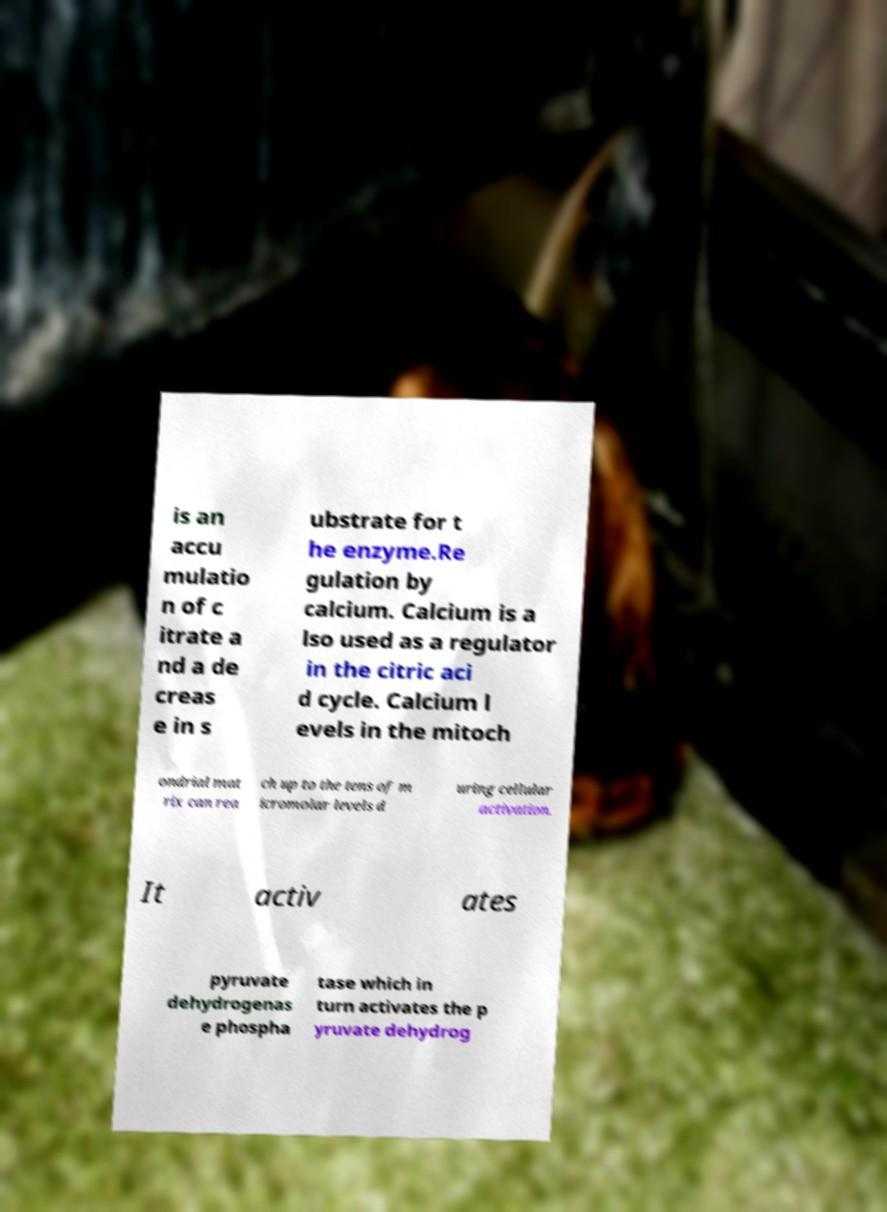What messages or text are displayed in this image? I need them in a readable, typed format. is an accu mulatio n of c itrate a nd a de creas e in s ubstrate for t he enzyme.Re gulation by calcium. Calcium is a lso used as a regulator in the citric aci d cycle. Calcium l evels in the mitoch ondrial mat rix can rea ch up to the tens of m icromolar levels d uring cellular activation. It activ ates pyruvate dehydrogenas e phospha tase which in turn activates the p yruvate dehydrog 